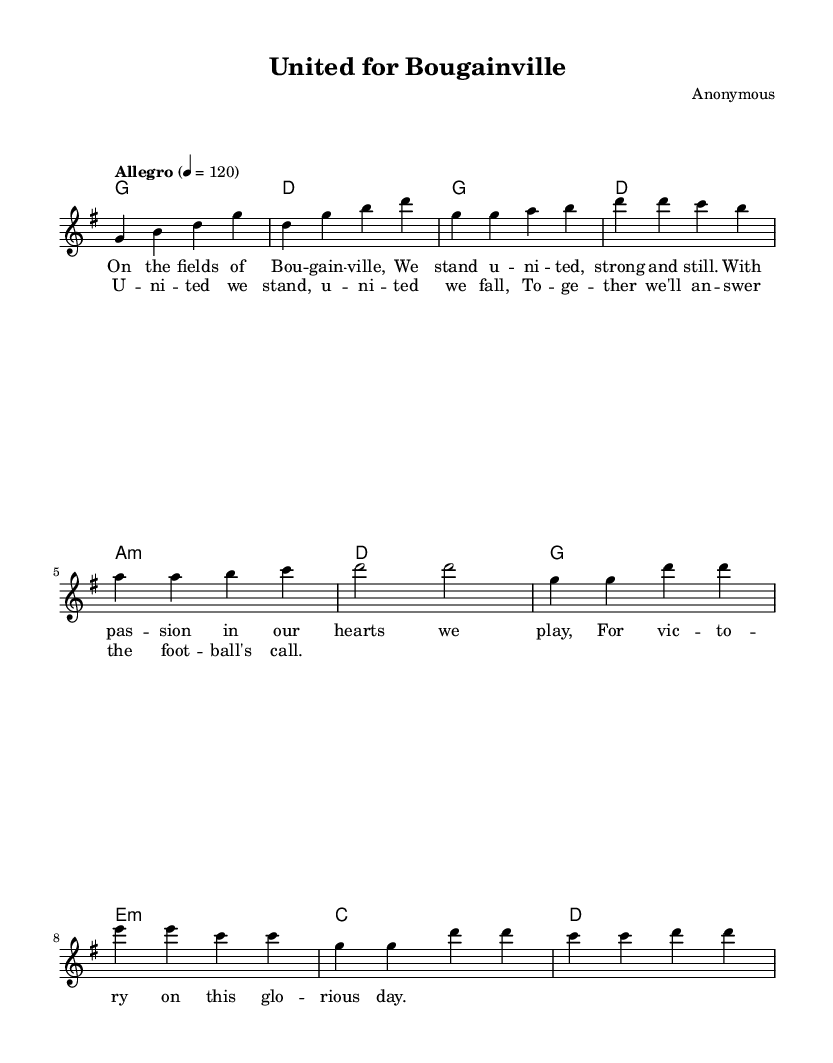What is the key signature of this music? The key signature of this piece is G major, which has one sharp (F#). You can determine this by looking for the key signature indicated at the beginning of the score, immediately after the \key command.
Answer: G major What is the time signature of this music? The time signature is 4/4, which indicates that there are four beats in each measure and each quarter note receives one beat. This can be seen at the start of the score where the \time command is defined.
Answer: 4/4 What is the tempo marking for this piece? The tempo marking is "Allegro," which indicates a lively and fast tempo. This is found in the global block where the tempo command is set.
Answer: Allegro How many measures are in the verse? The verse consists of four measures, as counted from the melody line where the verse lyrics are attached to the corresponding notes. This is determined by observing the structure in the melody section labeled as "Verse."
Answer: 4 In which section does the lyrics "United we stand, united we fall" appear? These lyrics appear in the chorus section, as indicated by the label for the chorus which separates it from the verse. The lyrics are explicitly linked to the musical line intended for the chorus.
Answer: Chorus What is the first note of the melody? The first note of the melody is G, which is visible as the first note in the melody line right after the initial introductory passage. You can find this by looking at the relative notation provided in the melody section.
Answer: G Which chord is played in the first measure? The chord played in the first measure is G. This is evident from the chord progression presented in the harmonies section, specifically at the beginning where G is stated.
Answer: G 